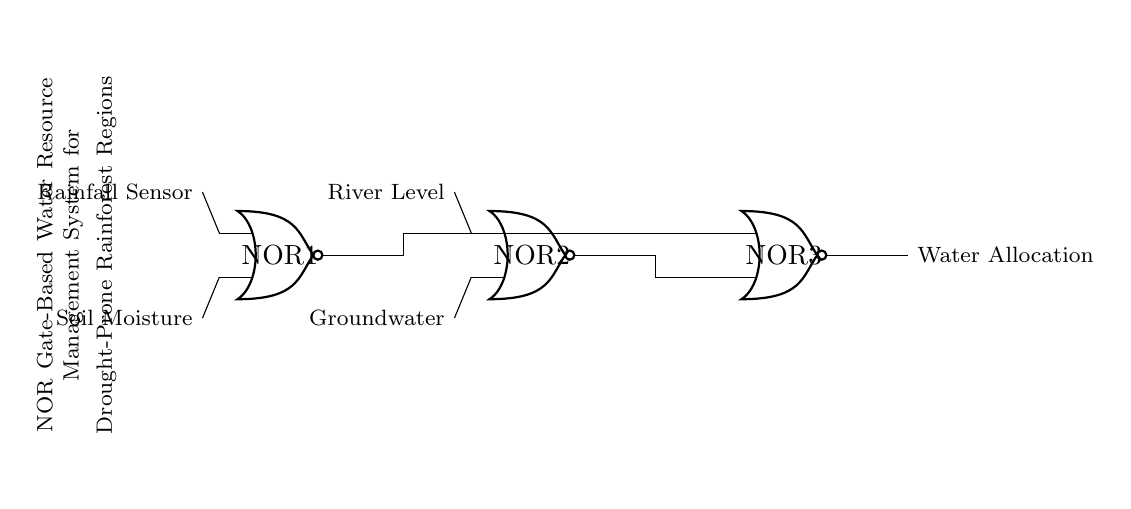What are the inputs to the first NOR gate? The inputs to the first NOR gate are the Rainfall Sensor and Soil Moisture. This can be identified by following the lines leading into NOR1 from these two sensors shown on the left side of the diagram.
Answer: Rainfall Sensor, Soil Moisture What is the output of the last NOR gate? The output of the last NOR gate (NOR3) is labeled as Water Allocation. This is indicated by the connection coming out of NOR3 which is marked with this label.
Answer: Water Allocation How many NOR gates are in the system? There are three NOR gates in the system. This is visible in the diagram, where three NOR gate symbols are displayed.
Answer: Three What role does the second NOR gate play? The second NOR gate (NOR2) processes the inputs from the River Level and Groundwater to contribute to the final output. It receives two environmental conditions as inputs and its output feeds into NOR3 for further processing.
Answer: Processing inputs Which inputs connect to the final NOR gate? The final NOR gate (NOR3) receives inputs from the outputs of the first two NOR gates (NOR1 and NOR2). This connection can be seen as the outputs of the first two gates are routed to the inputs of NOR3.
Answer: Outputs from NOR1 and NOR2 What is the function of a NOR gate in this circuit? In this circuit, a NOR gate functions as a logic gate that outputs false only when all its inputs are true. Thus, it serves to determine optimal conditions for water allocation based on the combined results of its input sensors.
Answer: Logic operation for allocation 